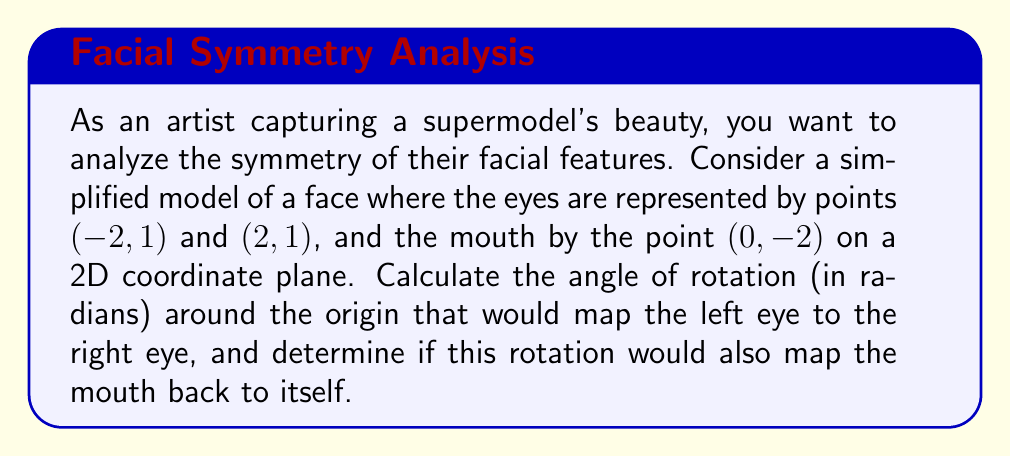Help me with this question. To solve this problem, we'll use the properties of rotations in the plane and the concept of symmetry.

1) First, let's consider the rotation that maps the left eye to the right eye:
   - Left eye: $(-2, 1)$
   - Right eye: $(2, 1)$

2) The rotation angle $\theta$ can be calculated using the arctangent function:
   $$\theta = \arctan(\frac{y}{x}) = \arctan(\frac{1}{2}) \approx 0.4636 \text{ radians}$$

3) However, this gives us the angle from the positive x-axis to the right eye. To get the full rotation angle, we need to double this:
   $$\theta_{full} = 2 \cdot \arctan(\frac{1}{2}) \approx 0.9273 \text{ radians}$$

4) Now, let's check if this rotation would map the mouth $(0, -2)$ back to itself:
   - The rotation matrix for $\theta_{full}$ is:
     $$R = \begin{pmatrix} 
     \cos(\theta_{full}) & -\sin(\theta_{full}) \\
     \sin(\theta_{full}) & \cos(\theta_{full})
     \end{pmatrix}$$

5) Applying this rotation to the mouth coordinates:
   $$\begin{pmatrix} 
   \cos(\theta_{full}) & -\sin(\theta_{full}) \\
   \sin(\theta_{full}) & \cos(\theta_{full})
   \end{pmatrix} \begin{pmatrix} 0 \\ -2 \end{pmatrix} = 
   \begin{pmatrix} 2\sin(\theta_{full}) \\ -2\cos(\theta_{full}) \end{pmatrix}$$

6) For the mouth to map back to itself, we need:
   $$2\sin(\theta_{full}) = 0 \text{ and } -2\cos(\theta_{full}) = -2$$

7) This is only true if $\theta_{full} = \pi$ radians (180 degrees), which is not the case here.

Therefore, while the rotation of $\theta_{full} \approx 0.9273$ radians maps the left eye to the right eye, it does not map the mouth back to itself, indicating that the face model is not perfectly symmetrical under this rotation.
Answer: The angle of rotation that maps the left eye to the right eye is approximately 0.9273 radians. This rotation does not map the mouth back to itself, indicating that the face model is not perfectly symmetrical under this rotation. 